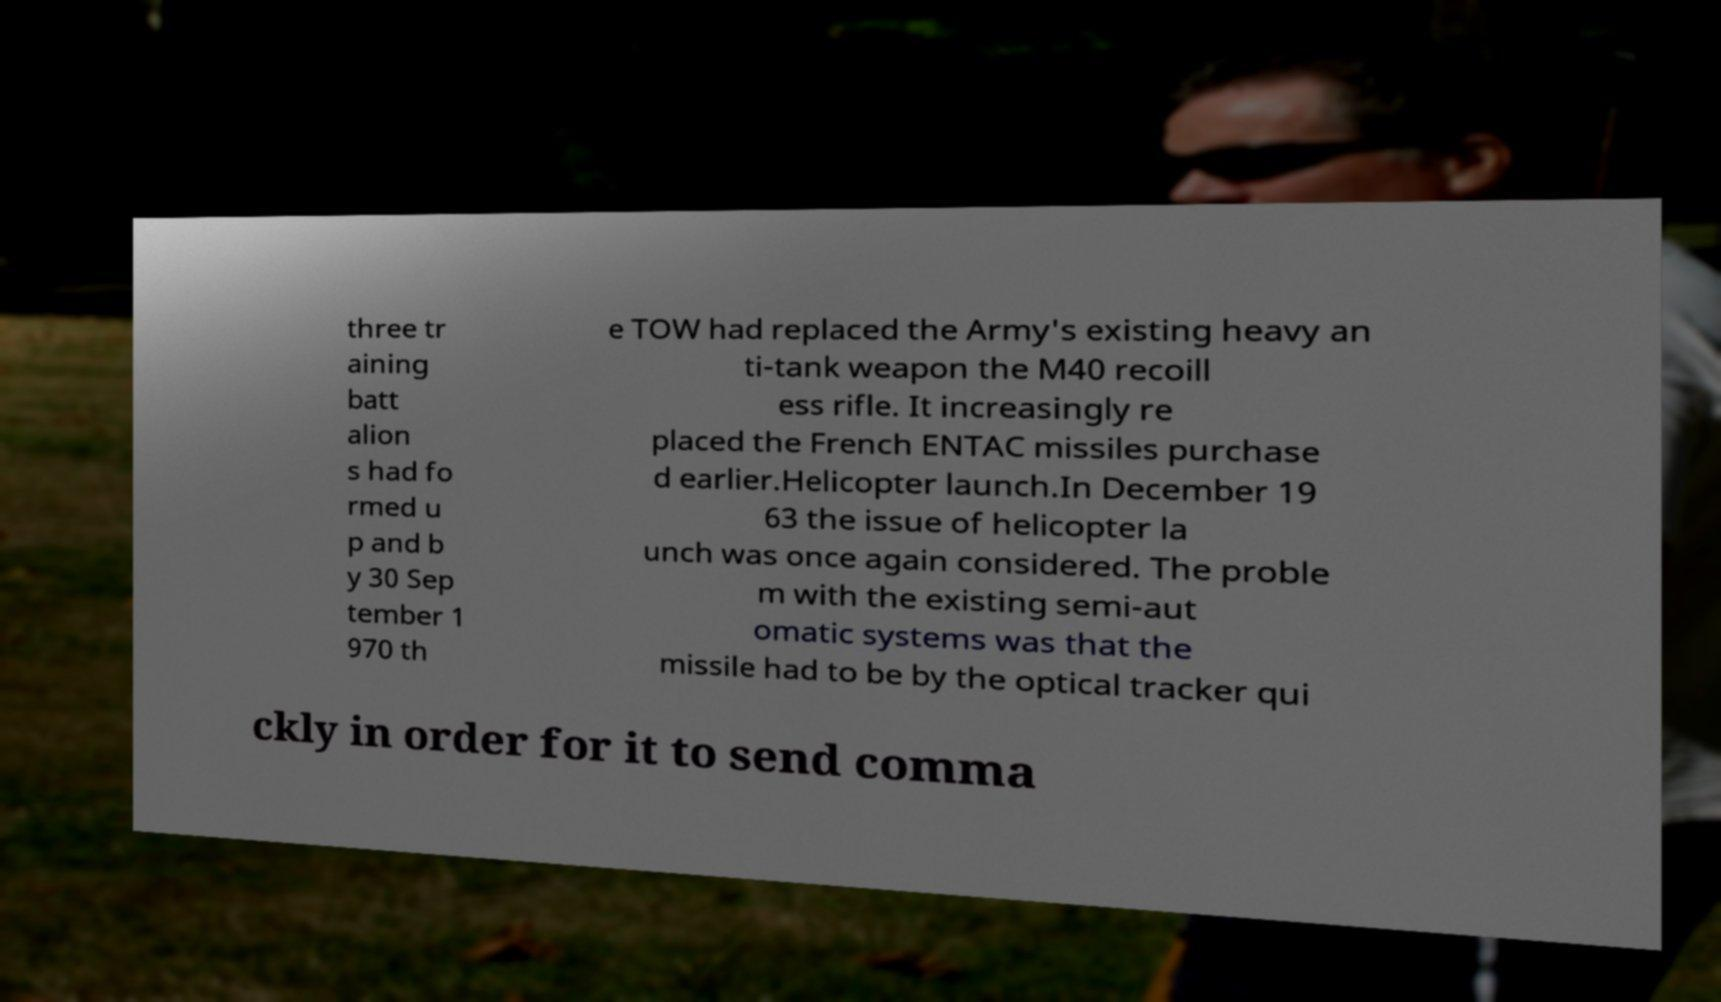What messages or text are displayed in this image? I need them in a readable, typed format. three tr aining batt alion s had fo rmed u p and b y 30 Sep tember 1 970 th e TOW had replaced the Army's existing heavy an ti-tank weapon the M40 recoill ess rifle. It increasingly re placed the French ENTAC missiles purchase d earlier.Helicopter launch.In December 19 63 the issue of helicopter la unch was once again considered. The proble m with the existing semi-aut omatic systems was that the missile had to be by the optical tracker qui ckly in order for it to send comma 